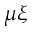<formula> <loc_0><loc_0><loc_500><loc_500>\mu \xi</formula> 